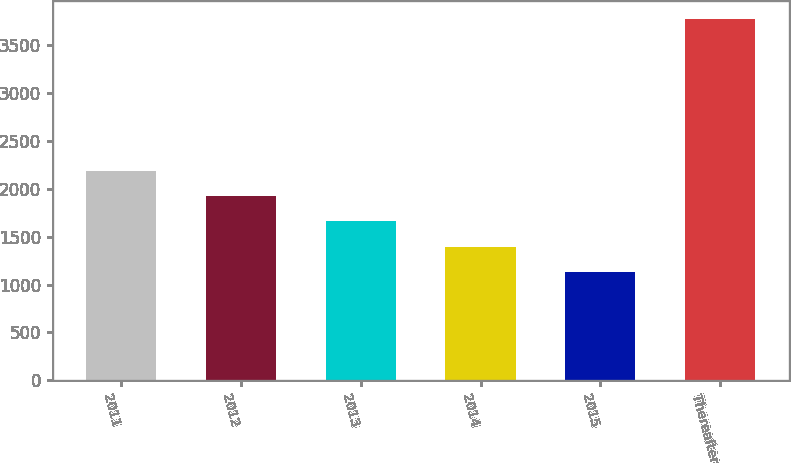<chart> <loc_0><loc_0><loc_500><loc_500><bar_chart><fcel>2011<fcel>2012<fcel>2013<fcel>2014<fcel>2015<fcel>Thereafter<nl><fcel>2188.6<fcel>1924.7<fcel>1660.8<fcel>1396.9<fcel>1133<fcel>3772<nl></chart> 